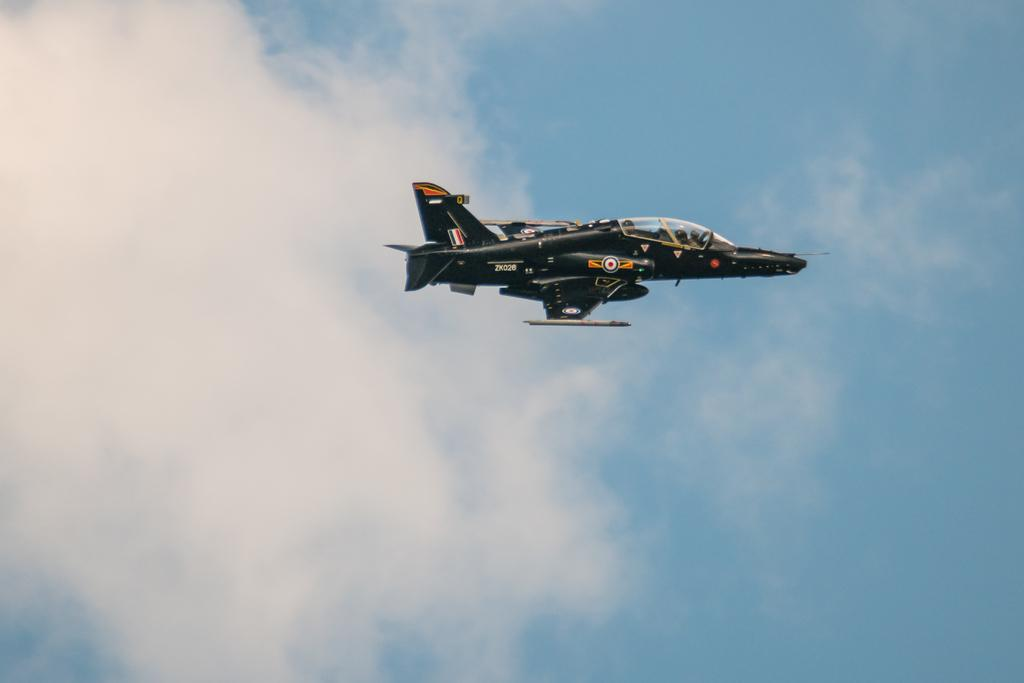What is the main subject of the image? The main subject of the image is an aircraft. What is the aircraft doing in the image? The aircraft is flying in the air. What can be seen in the background of the image? The sky and clouds are visible in the background of the image. How does the aircraft expand its wings while flying in the image? The aircraft does not expand its wings in the image; it is already flying with its wings fully extended. What type of request can be made to the aircraft in the image? There is no interaction with the aircraft in the image, so it is not possible to make a request to it. 